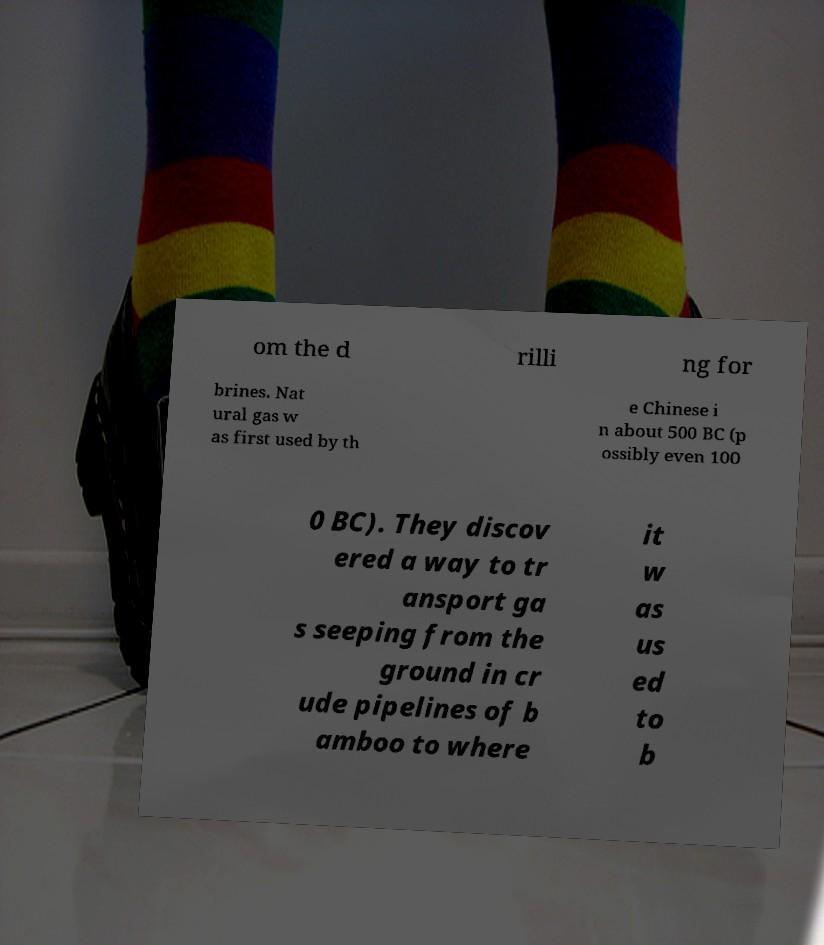What messages or text are displayed in this image? I need them in a readable, typed format. om the d rilli ng for brines. Nat ural gas w as first used by th e Chinese i n about 500 BC (p ossibly even 100 0 BC). They discov ered a way to tr ansport ga s seeping from the ground in cr ude pipelines of b amboo to where it w as us ed to b 